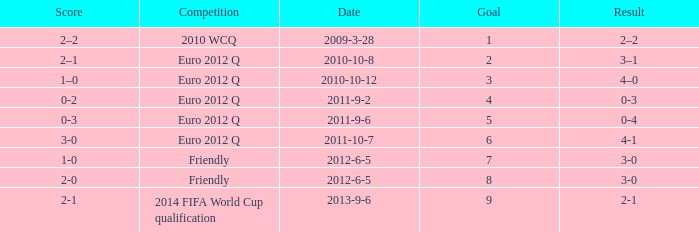How many goals when the score is 3-0 in the euro 2012 q? 1.0. 